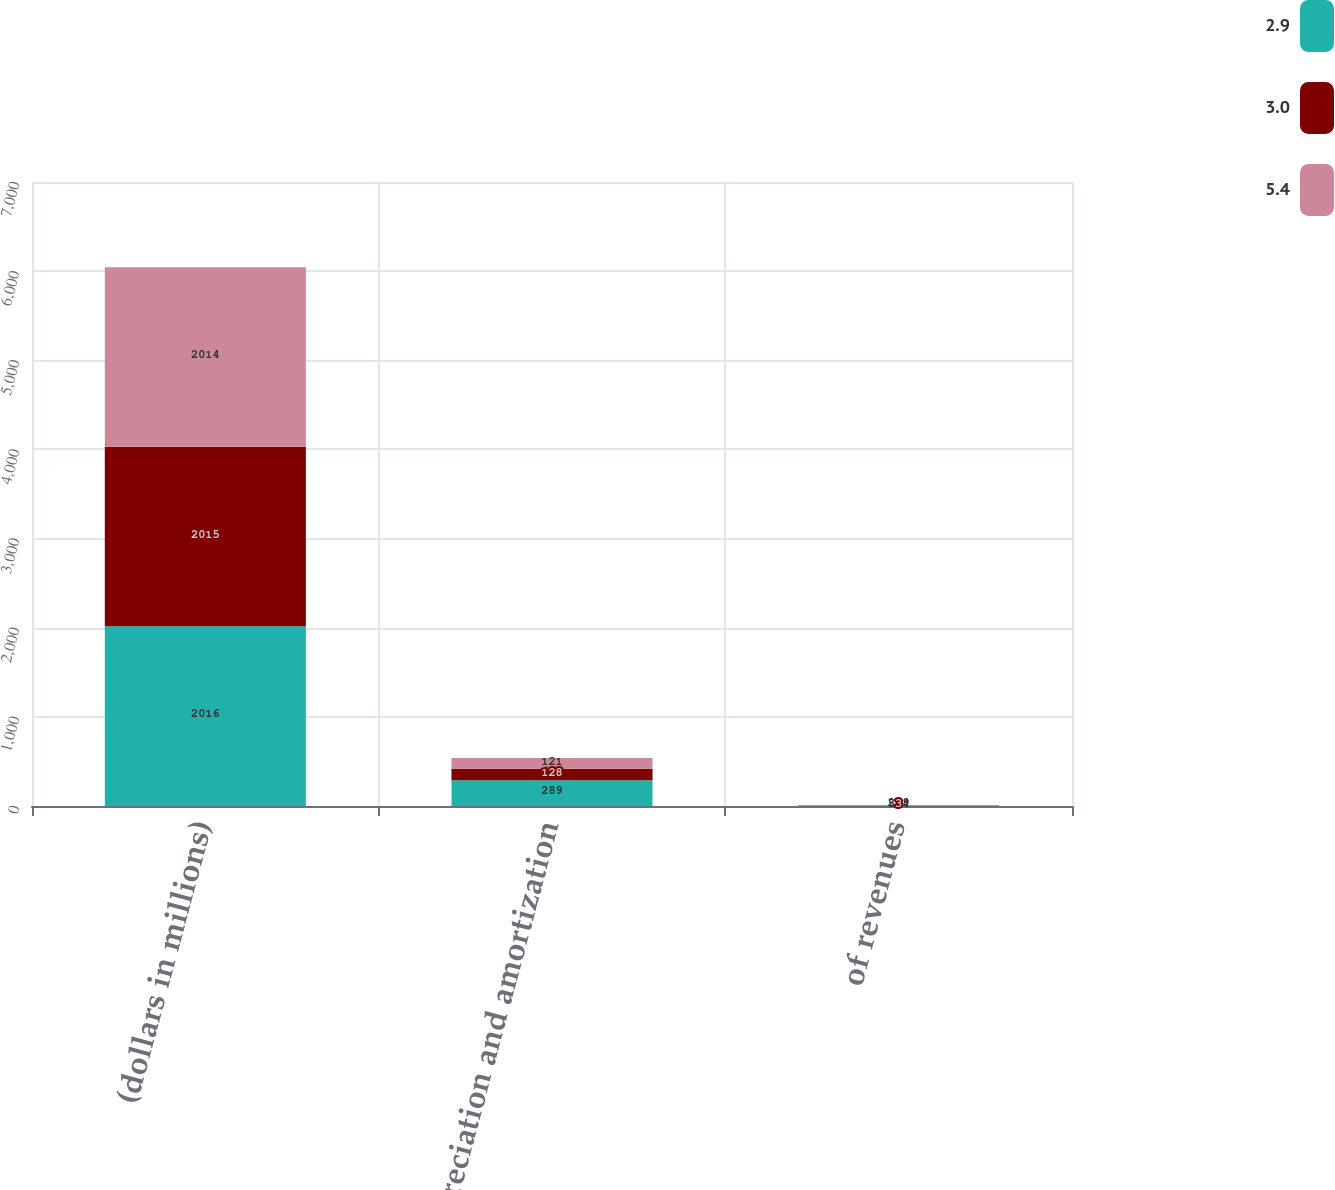<chart> <loc_0><loc_0><loc_500><loc_500><stacked_bar_chart><ecel><fcel>(dollars in millions)<fcel>Depreciation and amortization<fcel>of revenues<nl><fcel>2.9<fcel>2016<fcel>289<fcel>5.4<nl><fcel>3<fcel>2015<fcel>128<fcel>3<nl><fcel>5.4<fcel>2014<fcel>121<fcel>2.9<nl></chart> 